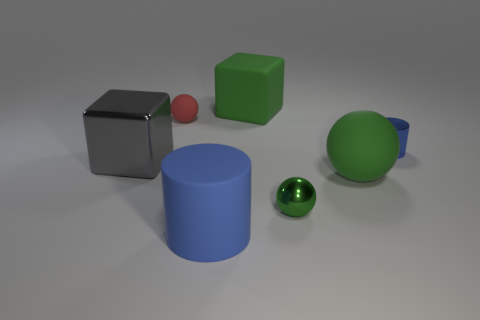Add 2 small cylinders. How many objects exist? 9 Subtract all cylinders. How many objects are left? 5 Subtract all tiny green matte objects. Subtract all shiny spheres. How many objects are left? 6 Add 3 small balls. How many small balls are left? 5 Add 6 small green spheres. How many small green spheres exist? 7 Subtract 1 blue cylinders. How many objects are left? 6 